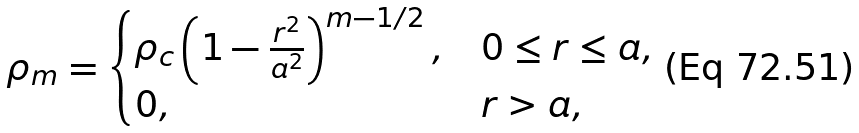Convert formula to latex. <formula><loc_0><loc_0><loc_500><loc_500>\rho _ { m } = \begin{cases} \rho _ { c } \left ( 1 - \frac { r ^ { 2 } } { a ^ { 2 } } \right ) ^ { m - 1 / 2 } , & 0 \leq r \leq a , \\ 0 , & r > a , \end{cases}</formula> 